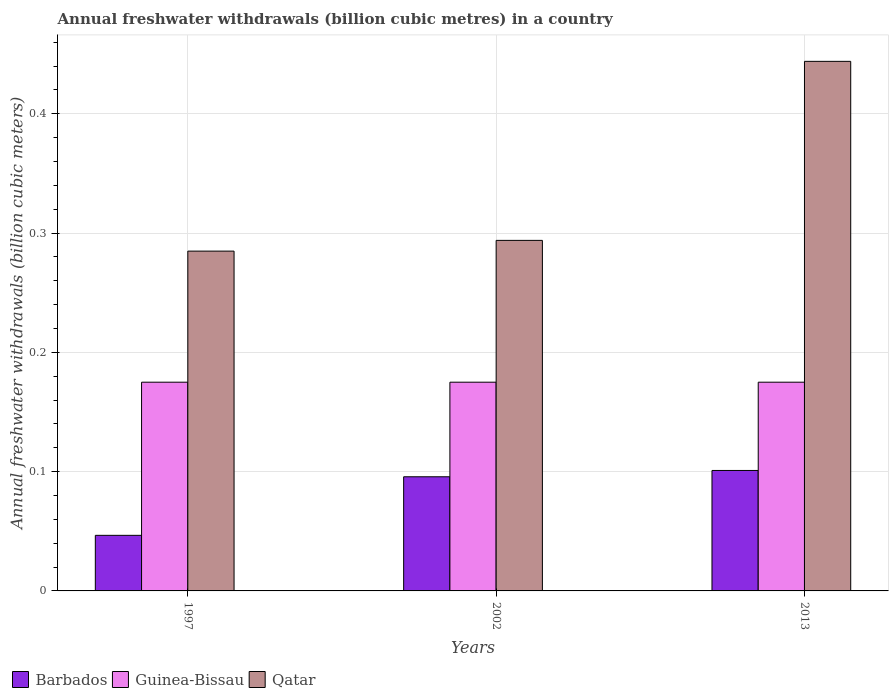How many groups of bars are there?
Your response must be concise. 3. Are the number of bars per tick equal to the number of legend labels?
Offer a very short reply. Yes. How many bars are there on the 1st tick from the right?
Provide a succinct answer. 3. What is the annual freshwater withdrawals in Barbados in 2002?
Give a very brief answer. 0.1. Across all years, what is the maximum annual freshwater withdrawals in Barbados?
Provide a succinct answer. 0.1. Across all years, what is the minimum annual freshwater withdrawals in Barbados?
Keep it short and to the point. 0.05. In which year was the annual freshwater withdrawals in Qatar maximum?
Your answer should be compact. 2013. What is the total annual freshwater withdrawals in Guinea-Bissau in the graph?
Your answer should be very brief. 0.52. What is the difference between the annual freshwater withdrawals in Guinea-Bissau in 1997 and that in 2002?
Provide a short and direct response. 0. What is the difference between the annual freshwater withdrawals in Qatar in 1997 and the annual freshwater withdrawals in Guinea-Bissau in 2013?
Make the answer very short. 0.11. What is the average annual freshwater withdrawals in Guinea-Bissau per year?
Offer a terse response. 0.17. In the year 1997, what is the difference between the annual freshwater withdrawals in Barbados and annual freshwater withdrawals in Guinea-Bissau?
Your answer should be very brief. -0.13. What is the ratio of the annual freshwater withdrawals in Guinea-Bissau in 2002 to that in 2013?
Ensure brevity in your answer.  1. Is the difference between the annual freshwater withdrawals in Barbados in 1997 and 2002 greater than the difference between the annual freshwater withdrawals in Guinea-Bissau in 1997 and 2002?
Ensure brevity in your answer.  No. What is the difference between the highest and the second highest annual freshwater withdrawals in Qatar?
Provide a short and direct response. 0.15. What is the difference between the highest and the lowest annual freshwater withdrawals in Guinea-Bissau?
Your response must be concise. 0. What does the 3rd bar from the left in 2002 represents?
Your answer should be compact. Qatar. What does the 3rd bar from the right in 2013 represents?
Your answer should be very brief. Barbados. Are all the bars in the graph horizontal?
Keep it short and to the point. No. What is the difference between two consecutive major ticks on the Y-axis?
Ensure brevity in your answer.  0.1. Are the values on the major ticks of Y-axis written in scientific E-notation?
Offer a terse response. No. Does the graph contain any zero values?
Your answer should be compact. No. What is the title of the graph?
Your answer should be very brief. Annual freshwater withdrawals (billion cubic metres) in a country. Does "Nepal" appear as one of the legend labels in the graph?
Offer a terse response. No. What is the label or title of the X-axis?
Offer a terse response. Years. What is the label or title of the Y-axis?
Keep it short and to the point. Annual freshwater withdrawals (billion cubic meters). What is the Annual freshwater withdrawals (billion cubic meters) of Barbados in 1997?
Keep it short and to the point. 0.05. What is the Annual freshwater withdrawals (billion cubic meters) in Guinea-Bissau in 1997?
Provide a succinct answer. 0.17. What is the Annual freshwater withdrawals (billion cubic meters) of Qatar in 1997?
Keep it short and to the point. 0.28. What is the Annual freshwater withdrawals (billion cubic meters) in Barbados in 2002?
Ensure brevity in your answer.  0.1. What is the Annual freshwater withdrawals (billion cubic meters) in Guinea-Bissau in 2002?
Offer a very short reply. 0.17. What is the Annual freshwater withdrawals (billion cubic meters) of Qatar in 2002?
Give a very brief answer. 0.29. What is the Annual freshwater withdrawals (billion cubic meters) in Barbados in 2013?
Provide a short and direct response. 0.1. What is the Annual freshwater withdrawals (billion cubic meters) of Guinea-Bissau in 2013?
Offer a very short reply. 0.17. What is the Annual freshwater withdrawals (billion cubic meters) of Qatar in 2013?
Offer a very short reply. 0.44. Across all years, what is the maximum Annual freshwater withdrawals (billion cubic meters) of Barbados?
Ensure brevity in your answer.  0.1. Across all years, what is the maximum Annual freshwater withdrawals (billion cubic meters) in Guinea-Bissau?
Your answer should be very brief. 0.17. Across all years, what is the maximum Annual freshwater withdrawals (billion cubic meters) in Qatar?
Ensure brevity in your answer.  0.44. Across all years, what is the minimum Annual freshwater withdrawals (billion cubic meters) of Barbados?
Make the answer very short. 0.05. Across all years, what is the minimum Annual freshwater withdrawals (billion cubic meters) of Guinea-Bissau?
Offer a very short reply. 0.17. Across all years, what is the minimum Annual freshwater withdrawals (billion cubic meters) in Qatar?
Ensure brevity in your answer.  0.28. What is the total Annual freshwater withdrawals (billion cubic meters) of Barbados in the graph?
Offer a terse response. 0.24. What is the total Annual freshwater withdrawals (billion cubic meters) in Guinea-Bissau in the graph?
Your response must be concise. 0.53. What is the total Annual freshwater withdrawals (billion cubic meters) of Qatar in the graph?
Keep it short and to the point. 1.02. What is the difference between the Annual freshwater withdrawals (billion cubic meters) in Barbados in 1997 and that in 2002?
Your answer should be very brief. -0.05. What is the difference between the Annual freshwater withdrawals (billion cubic meters) of Qatar in 1997 and that in 2002?
Offer a very short reply. -0.01. What is the difference between the Annual freshwater withdrawals (billion cubic meters) in Barbados in 1997 and that in 2013?
Give a very brief answer. -0.05. What is the difference between the Annual freshwater withdrawals (billion cubic meters) of Qatar in 1997 and that in 2013?
Ensure brevity in your answer.  -0.16. What is the difference between the Annual freshwater withdrawals (billion cubic meters) of Barbados in 2002 and that in 2013?
Give a very brief answer. -0.01. What is the difference between the Annual freshwater withdrawals (billion cubic meters) in Guinea-Bissau in 2002 and that in 2013?
Keep it short and to the point. 0. What is the difference between the Annual freshwater withdrawals (billion cubic meters) of Qatar in 2002 and that in 2013?
Your answer should be very brief. -0.15. What is the difference between the Annual freshwater withdrawals (billion cubic meters) of Barbados in 1997 and the Annual freshwater withdrawals (billion cubic meters) of Guinea-Bissau in 2002?
Offer a terse response. -0.13. What is the difference between the Annual freshwater withdrawals (billion cubic meters) in Barbados in 1997 and the Annual freshwater withdrawals (billion cubic meters) in Qatar in 2002?
Your answer should be compact. -0.25. What is the difference between the Annual freshwater withdrawals (billion cubic meters) in Guinea-Bissau in 1997 and the Annual freshwater withdrawals (billion cubic meters) in Qatar in 2002?
Your response must be concise. -0.12. What is the difference between the Annual freshwater withdrawals (billion cubic meters) in Barbados in 1997 and the Annual freshwater withdrawals (billion cubic meters) in Guinea-Bissau in 2013?
Provide a short and direct response. -0.13. What is the difference between the Annual freshwater withdrawals (billion cubic meters) of Barbados in 1997 and the Annual freshwater withdrawals (billion cubic meters) of Qatar in 2013?
Give a very brief answer. -0.4. What is the difference between the Annual freshwater withdrawals (billion cubic meters) of Guinea-Bissau in 1997 and the Annual freshwater withdrawals (billion cubic meters) of Qatar in 2013?
Your response must be concise. -0.27. What is the difference between the Annual freshwater withdrawals (billion cubic meters) of Barbados in 2002 and the Annual freshwater withdrawals (billion cubic meters) of Guinea-Bissau in 2013?
Your answer should be very brief. -0.08. What is the difference between the Annual freshwater withdrawals (billion cubic meters) in Barbados in 2002 and the Annual freshwater withdrawals (billion cubic meters) in Qatar in 2013?
Your response must be concise. -0.35. What is the difference between the Annual freshwater withdrawals (billion cubic meters) in Guinea-Bissau in 2002 and the Annual freshwater withdrawals (billion cubic meters) in Qatar in 2013?
Keep it short and to the point. -0.27. What is the average Annual freshwater withdrawals (billion cubic meters) in Barbados per year?
Ensure brevity in your answer.  0.08. What is the average Annual freshwater withdrawals (billion cubic meters) in Guinea-Bissau per year?
Ensure brevity in your answer.  0.17. What is the average Annual freshwater withdrawals (billion cubic meters) of Qatar per year?
Ensure brevity in your answer.  0.34. In the year 1997, what is the difference between the Annual freshwater withdrawals (billion cubic meters) in Barbados and Annual freshwater withdrawals (billion cubic meters) in Guinea-Bissau?
Keep it short and to the point. -0.13. In the year 1997, what is the difference between the Annual freshwater withdrawals (billion cubic meters) of Barbados and Annual freshwater withdrawals (billion cubic meters) of Qatar?
Provide a succinct answer. -0.24. In the year 1997, what is the difference between the Annual freshwater withdrawals (billion cubic meters) of Guinea-Bissau and Annual freshwater withdrawals (billion cubic meters) of Qatar?
Ensure brevity in your answer.  -0.11. In the year 2002, what is the difference between the Annual freshwater withdrawals (billion cubic meters) of Barbados and Annual freshwater withdrawals (billion cubic meters) of Guinea-Bissau?
Provide a short and direct response. -0.08. In the year 2002, what is the difference between the Annual freshwater withdrawals (billion cubic meters) of Barbados and Annual freshwater withdrawals (billion cubic meters) of Qatar?
Keep it short and to the point. -0.2. In the year 2002, what is the difference between the Annual freshwater withdrawals (billion cubic meters) in Guinea-Bissau and Annual freshwater withdrawals (billion cubic meters) in Qatar?
Make the answer very short. -0.12. In the year 2013, what is the difference between the Annual freshwater withdrawals (billion cubic meters) in Barbados and Annual freshwater withdrawals (billion cubic meters) in Guinea-Bissau?
Keep it short and to the point. -0.07. In the year 2013, what is the difference between the Annual freshwater withdrawals (billion cubic meters) of Barbados and Annual freshwater withdrawals (billion cubic meters) of Qatar?
Keep it short and to the point. -0.34. In the year 2013, what is the difference between the Annual freshwater withdrawals (billion cubic meters) of Guinea-Bissau and Annual freshwater withdrawals (billion cubic meters) of Qatar?
Your answer should be very brief. -0.27. What is the ratio of the Annual freshwater withdrawals (billion cubic meters) of Barbados in 1997 to that in 2002?
Keep it short and to the point. 0.49. What is the ratio of the Annual freshwater withdrawals (billion cubic meters) of Qatar in 1997 to that in 2002?
Offer a very short reply. 0.97. What is the ratio of the Annual freshwater withdrawals (billion cubic meters) in Barbados in 1997 to that in 2013?
Offer a terse response. 0.46. What is the ratio of the Annual freshwater withdrawals (billion cubic meters) of Guinea-Bissau in 1997 to that in 2013?
Provide a short and direct response. 1. What is the ratio of the Annual freshwater withdrawals (billion cubic meters) of Qatar in 1997 to that in 2013?
Give a very brief answer. 0.64. What is the ratio of the Annual freshwater withdrawals (billion cubic meters) of Barbados in 2002 to that in 2013?
Offer a terse response. 0.95. What is the ratio of the Annual freshwater withdrawals (billion cubic meters) of Guinea-Bissau in 2002 to that in 2013?
Provide a short and direct response. 1. What is the ratio of the Annual freshwater withdrawals (billion cubic meters) of Qatar in 2002 to that in 2013?
Provide a short and direct response. 0.66. What is the difference between the highest and the second highest Annual freshwater withdrawals (billion cubic meters) in Barbados?
Your response must be concise. 0.01. What is the difference between the highest and the second highest Annual freshwater withdrawals (billion cubic meters) of Qatar?
Your answer should be very brief. 0.15. What is the difference between the highest and the lowest Annual freshwater withdrawals (billion cubic meters) in Barbados?
Your response must be concise. 0.05. What is the difference between the highest and the lowest Annual freshwater withdrawals (billion cubic meters) of Guinea-Bissau?
Make the answer very short. 0. What is the difference between the highest and the lowest Annual freshwater withdrawals (billion cubic meters) in Qatar?
Provide a short and direct response. 0.16. 